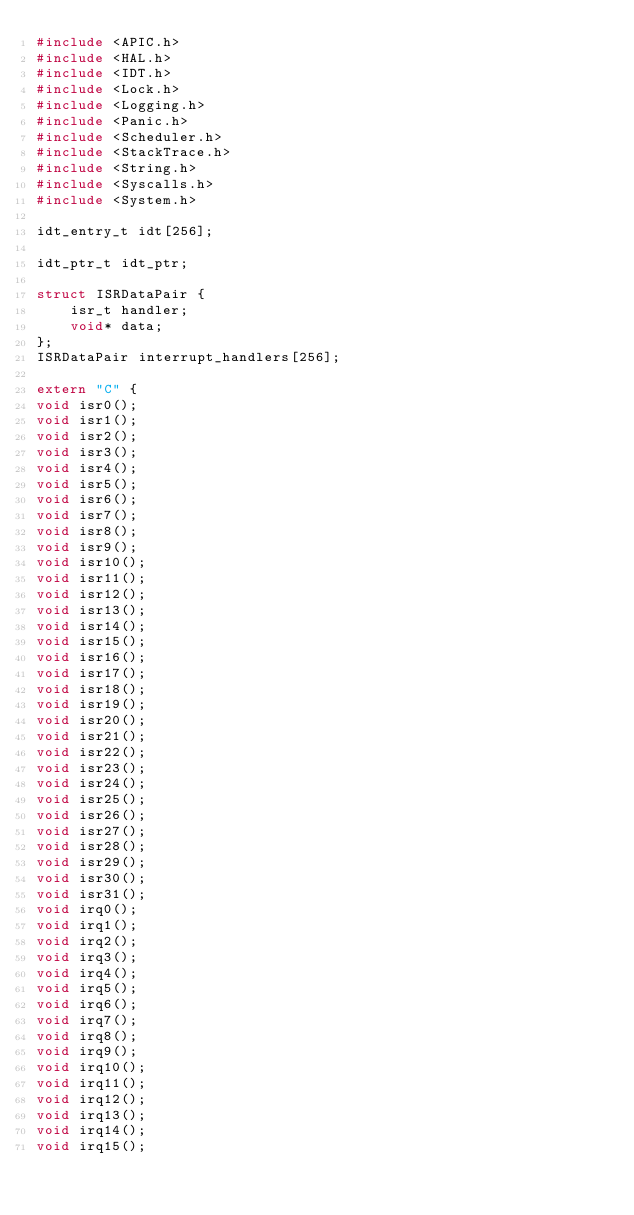<code> <loc_0><loc_0><loc_500><loc_500><_C++_>#include <APIC.h>
#include <HAL.h>
#include <IDT.h>
#include <Lock.h>
#include <Logging.h>
#include <Panic.h>
#include <Scheduler.h>
#include <StackTrace.h>
#include <String.h>
#include <Syscalls.h>
#include <System.h>

idt_entry_t idt[256];

idt_ptr_t idt_ptr;

struct ISRDataPair {
    isr_t handler;
    void* data;
};
ISRDataPair interrupt_handlers[256];

extern "C" {
void isr0();
void isr1();
void isr2();
void isr3();
void isr4();
void isr5();
void isr6();
void isr7();
void isr8();
void isr9();
void isr10();
void isr11();
void isr12();
void isr13();
void isr14();
void isr15();
void isr16();
void isr17();
void isr18();
void isr19();
void isr20();
void isr21();
void isr22();
void isr23();
void isr24();
void isr25();
void isr26();
void isr27();
void isr28();
void isr29();
void isr30();
void isr31();
void irq0();
void irq1();
void irq2();
void irq3();
void irq4();
void irq5();
void irq6();
void irq7();
void irq8();
void irq9();
void irq10();
void irq11();
void irq12();
void irq13();
void irq14();
void irq15();</code> 